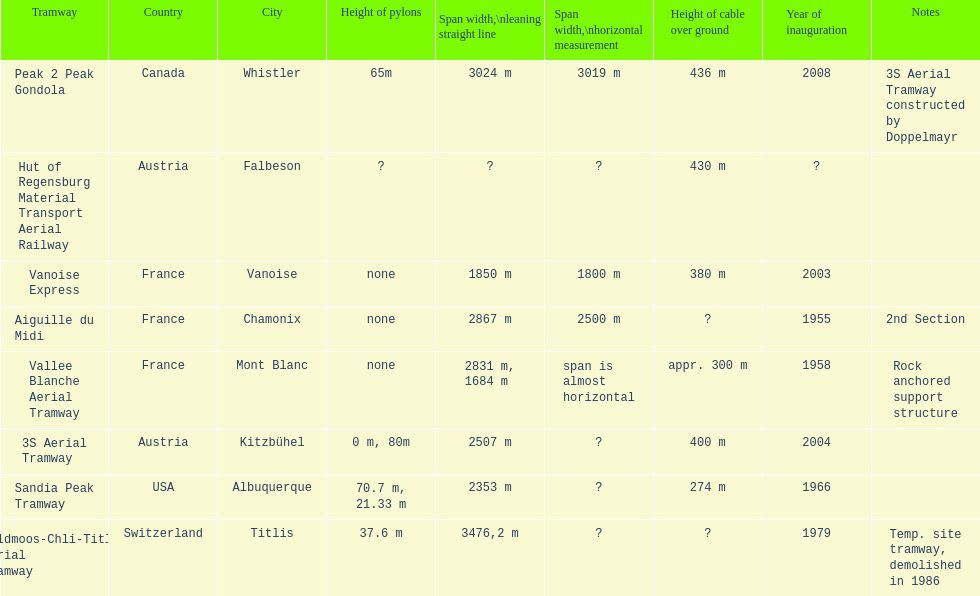What is the difference in length between the peak 2 peak gondola and the 32 aerial tramway? 517. 